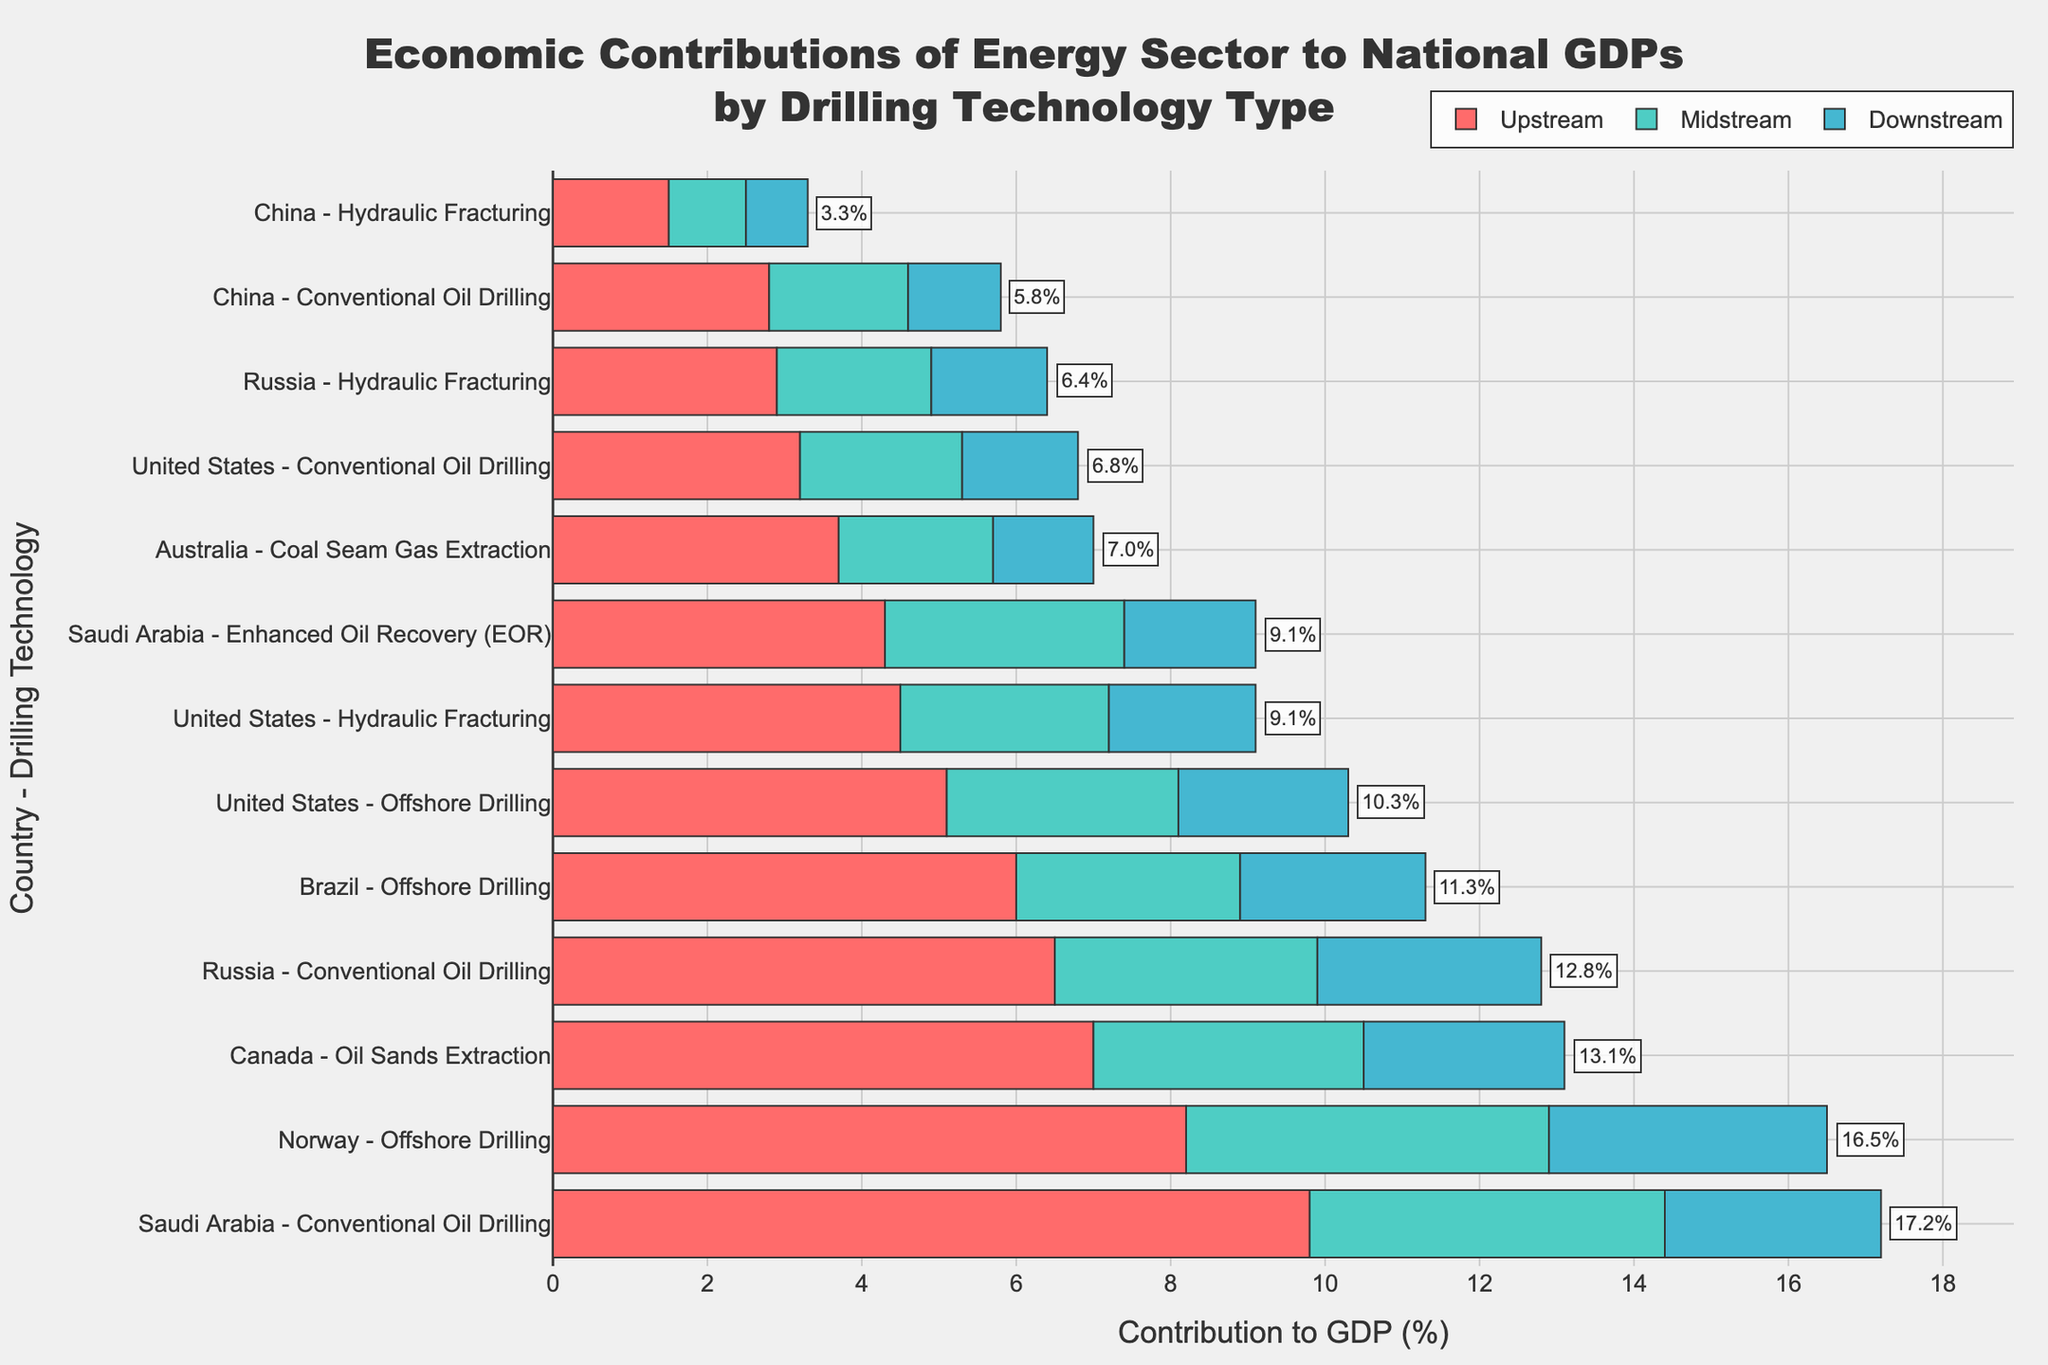Which country has the highest total contribution to GDP from Offshore Drilling? By looking at the chart, the total contribution to GDP from Offshore Drilling is represented visually. Comparing the heights of the combined Upstream, Midstream, and Downstream contributions, Norway has the highest total contribution from Offshore Drilling.
Answer: Norway What is the difference in total GDP contribution between Hydraulic Fracturing and Conventional Oil Drilling in the United States? Sum up the contributions from Upstream, Midstream, and Downstream for both technologies in the U.S.: Hydraulic Fracturing (4.5 + 2.7 + 1.9 = 9.1), Conventional Oil Drilling (3.2 + 2.1 + 1.5 = 6.8). The difference is 9.1 - 6.8.
Answer: 2.3 Which country and drilling technology have the smallest Midstream contribution to GDP? By observing the Midstream portion of the bar chart for each entry, China with Hydraulic Fracturing has the smallest Midstream contribution, which is 1.0%.
Answer: China - Hydraulic Fracturing What is the combined total GDP contribution of all drilling technologies in Russia? Sum the total contributions for each technology in Russia: Conventional Oil Drilling (6.5 + 3.4 + 2.9 = 12.8), Hydraulic Fracturing (2.9 + 2.0 + 1.5 = 6.4). The combined total is 12.8 + 6.4.
Answer: 19.2 How much greater is Saudi Arabia’s total contribution to GDP from Conventional Oil Drilling compared to Enhanced Oil Recovery (EOR)? Calculate the total contributions: Conventional Oil Drilling (9.8 + 4.6 + 2.8 = 17.2), EOR (4.3 + 3.1 + 1.7 = 9.1). The difference is 17.2 - 9.1.
Answer: 8.1 Which technology in Brazil contributes the most to GDP, and how much is it? Brazil only has Offshore Drilling represented. Sum the contributions: 6.0 (Upstream) + 2.9 (Midstream) + 2.4 (Downstream). The total contribution is 11.3%.
Answer: Offshore Drilling - 11.3% What is the average total GDP contribution from Offshore Drilling across all countries? Calculate the total contributions from Offshore Drilling for each country: USA (5.1 + 3.0 + 2.2 = 10.3), Norway (8.2 + 4.7 + 3.6 = 16.5), Brazil (6.0 + 2.9 + 2.4 = 11.3). The average is (10.3 + 16.5 + 11.3) / 3.
Answer: 12.7 